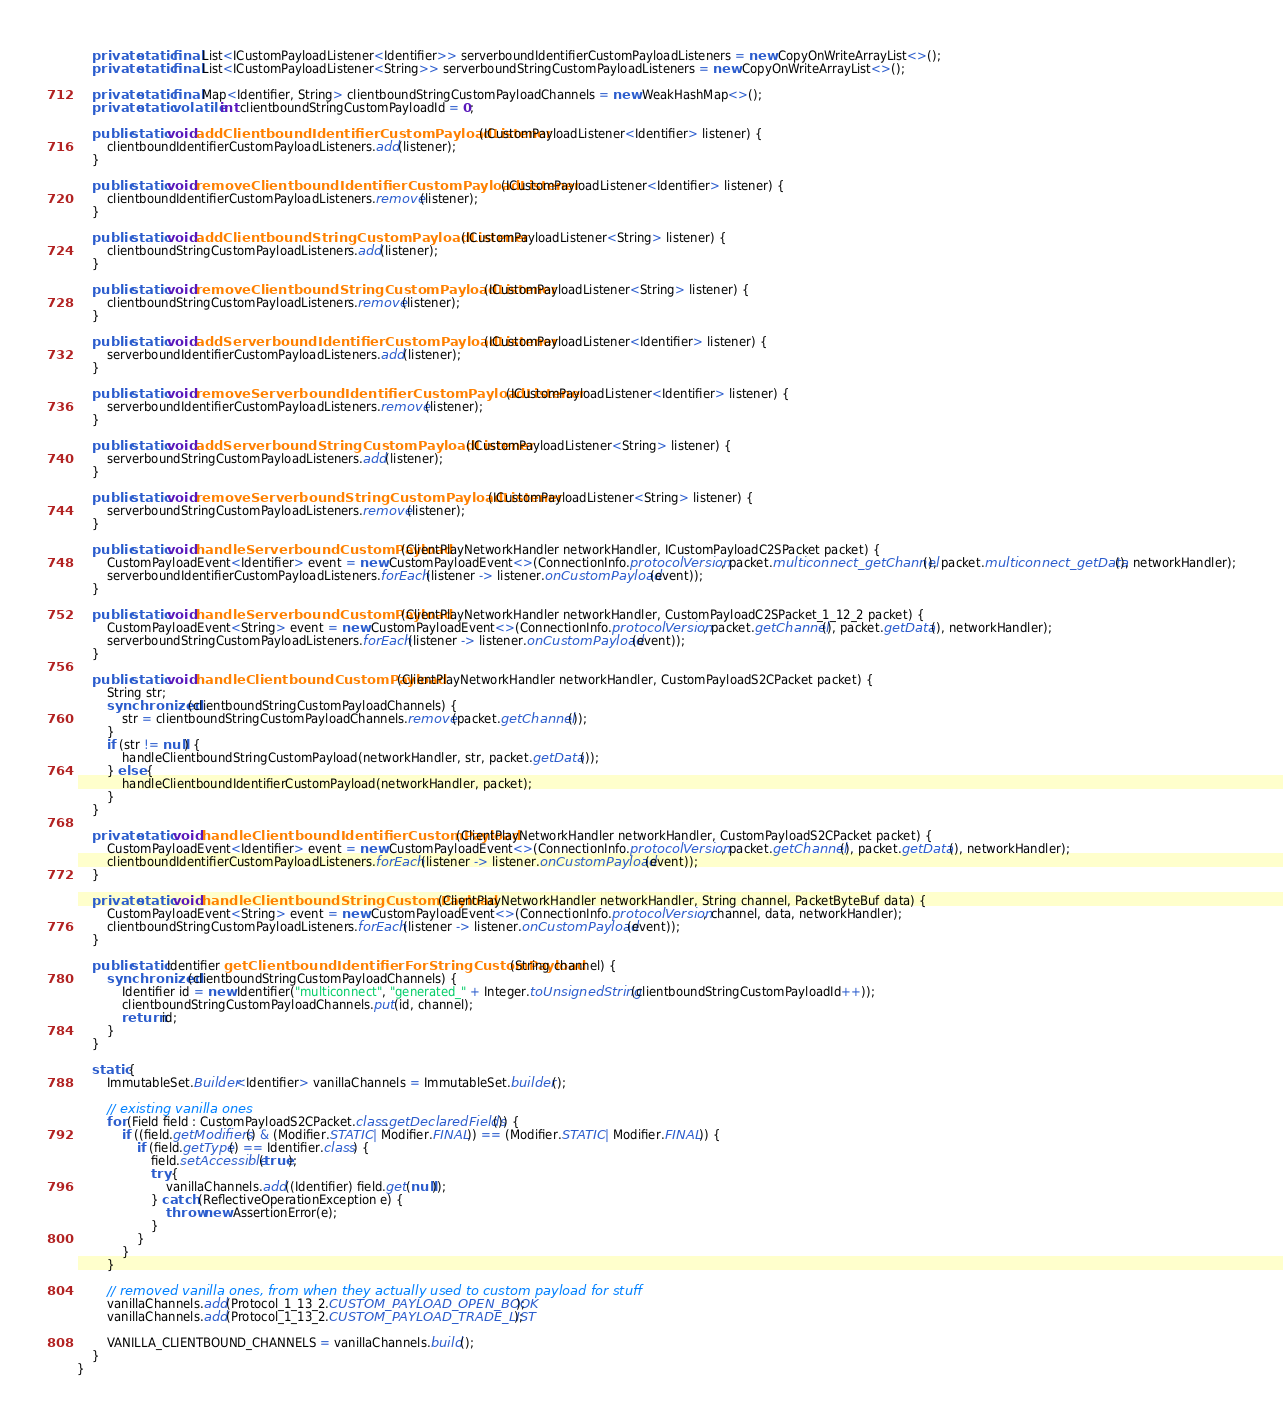Convert code to text. <code><loc_0><loc_0><loc_500><loc_500><_Java_>    private static final List<ICustomPayloadListener<Identifier>> serverboundIdentifierCustomPayloadListeners = new CopyOnWriteArrayList<>();
    private static final List<ICustomPayloadListener<String>> serverboundStringCustomPayloadListeners = new CopyOnWriteArrayList<>();

    private static final Map<Identifier, String> clientboundStringCustomPayloadChannels = new WeakHashMap<>();
    private static volatile int clientboundStringCustomPayloadId = 0;

    public static void addClientboundIdentifierCustomPayloadListener(ICustomPayloadListener<Identifier> listener) {
        clientboundIdentifierCustomPayloadListeners.add(listener);
    }

    public static void removeClientboundIdentifierCustomPayloadListener(ICustomPayloadListener<Identifier> listener) {
        clientboundIdentifierCustomPayloadListeners.remove(listener);
    }

    public static void addClientboundStringCustomPayloadListener(ICustomPayloadListener<String> listener) {
        clientboundStringCustomPayloadListeners.add(listener);
    }

    public static void removeClientboundStringCustomPayloadListener(ICustomPayloadListener<String> listener) {
        clientboundStringCustomPayloadListeners.remove(listener);
    }

    public static void addServerboundIdentifierCustomPayloadListener(ICustomPayloadListener<Identifier> listener) {
        serverboundIdentifierCustomPayloadListeners.add(listener);
    }

    public static void removeServerboundIdentifierCustomPayloadListener(ICustomPayloadListener<Identifier> listener) {
        serverboundIdentifierCustomPayloadListeners.remove(listener);
    }

    public static void addServerboundStringCustomPayloadListener(ICustomPayloadListener<String> listener) {
        serverboundStringCustomPayloadListeners.add(listener);
    }

    public static void removeServerboundStringCustomPayloadListener(ICustomPayloadListener<String> listener) {
        serverboundStringCustomPayloadListeners.remove(listener);
    }

    public static void handleServerboundCustomPayload(ClientPlayNetworkHandler networkHandler, ICustomPayloadC2SPacket packet) {
        CustomPayloadEvent<Identifier> event = new CustomPayloadEvent<>(ConnectionInfo.protocolVersion, packet.multiconnect_getChannel(), packet.multiconnect_getData(), networkHandler);
        serverboundIdentifierCustomPayloadListeners.forEach(listener -> listener.onCustomPayload(event));
    }

    public static void handleServerboundCustomPayload(ClientPlayNetworkHandler networkHandler, CustomPayloadC2SPacket_1_12_2 packet) {
        CustomPayloadEvent<String> event = new CustomPayloadEvent<>(ConnectionInfo.protocolVersion, packet.getChannel(), packet.getData(), networkHandler);
        serverboundStringCustomPayloadListeners.forEach(listener -> listener.onCustomPayload(event));
    }

    public static void handleClientboundCustomPayload(ClientPlayNetworkHandler networkHandler, CustomPayloadS2CPacket packet) {
        String str;
        synchronized (clientboundStringCustomPayloadChannels) {
            str = clientboundStringCustomPayloadChannels.remove(packet.getChannel());
        }
        if (str != null) {
            handleClientboundStringCustomPayload(networkHandler, str, packet.getData());
        } else {
            handleClientboundIdentifierCustomPayload(networkHandler, packet);
        }
    }

    private static void handleClientboundIdentifierCustomPayload(ClientPlayNetworkHandler networkHandler, CustomPayloadS2CPacket packet) {
        CustomPayloadEvent<Identifier> event = new CustomPayloadEvent<>(ConnectionInfo.protocolVersion, packet.getChannel(), packet.getData(), networkHandler);
        clientboundIdentifierCustomPayloadListeners.forEach(listener -> listener.onCustomPayload(event));
    }

    private static void handleClientboundStringCustomPayload(ClientPlayNetworkHandler networkHandler, String channel, PacketByteBuf data) {
        CustomPayloadEvent<String> event = new CustomPayloadEvent<>(ConnectionInfo.protocolVersion, channel, data, networkHandler);
        clientboundStringCustomPayloadListeners.forEach(listener -> listener.onCustomPayload(event));
    }

    public static Identifier getClientboundIdentifierForStringCustomPayload(String channel) {
        synchronized (clientboundStringCustomPayloadChannels) {
            Identifier id = new Identifier("multiconnect", "generated_" + Integer.toUnsignedString(clientboundStringCustomPayloadId++));
            clientboundStringCustomPayloadChannels.put(id, channel);
            return id;
        }
    }

    static {
        ImmutableSet.Builder<Identifier> vanillaChannels = ImmutableSet.builder();

        // existing vanilla ones
        for (Field field : CustomPayloadS2CPacket.class.getDeclaredFields()) {
            if ((field.getModifiers() & (Modifier.STATIC | Modifier.FINAL)) == (Modifier.STATIC | Modifier.FINAL)) {
                if (field.getType() == Identifier.class) {
                    field.setAccessible(true);
                    try {
                        vanillaChannels.add((Identifier) field.get(null));
                    } catch (ReflectiveOperationException e) {
                        throw new AssertionError(e);
                    }
                }
            }
        }

        // removed vanilla ones, from when they actually used to custom payload for stuff
        vanillaChannels.add(Protocol_1_13_2.CUSTOM_PAYLOAD_OPEN_BOOK);
        vanillaChannels.add(Protocol_1_13_2.CUSTOM_PAYLOAD_TRADE_LIST);

        VANILLA_CLIENTBOUND_CHANNELS = vanillaChannels.build();
    }
}
</code> 